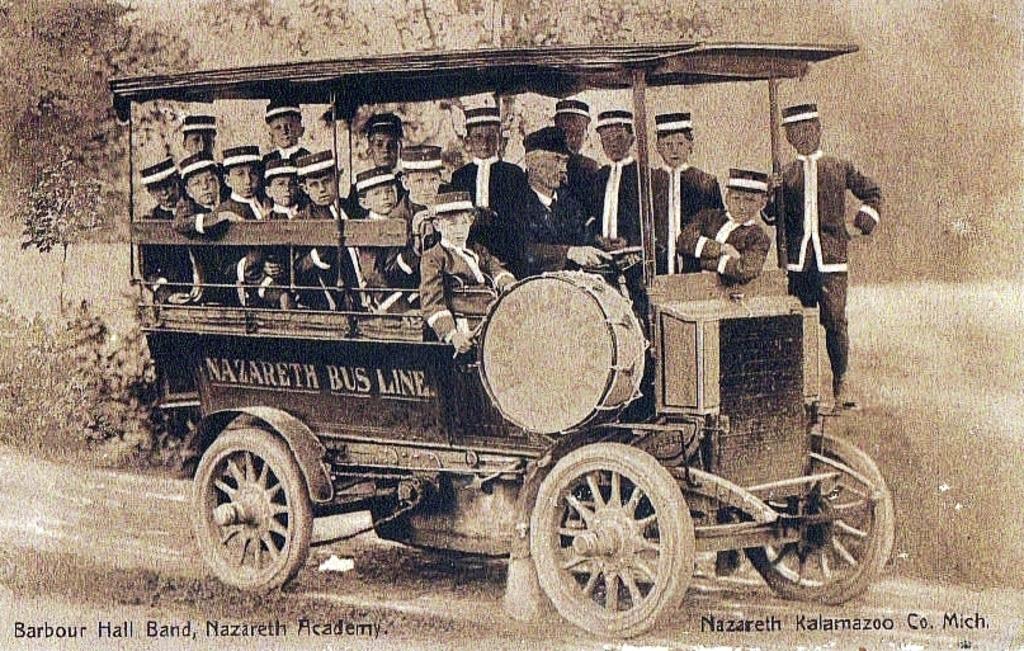Could you give a brief overview of what you see in this image? This picture is a black and white image. In this image we can see one vehicle on the road, one man driving the vehicle, some text on the vehicle, some boys standing on the vehicle, some boys sitting in the vehicle, one boy playing the drum with drumsticks, some trees and plants on the ground. Some text on the bottom right and left side of the image. The image is blurred. 